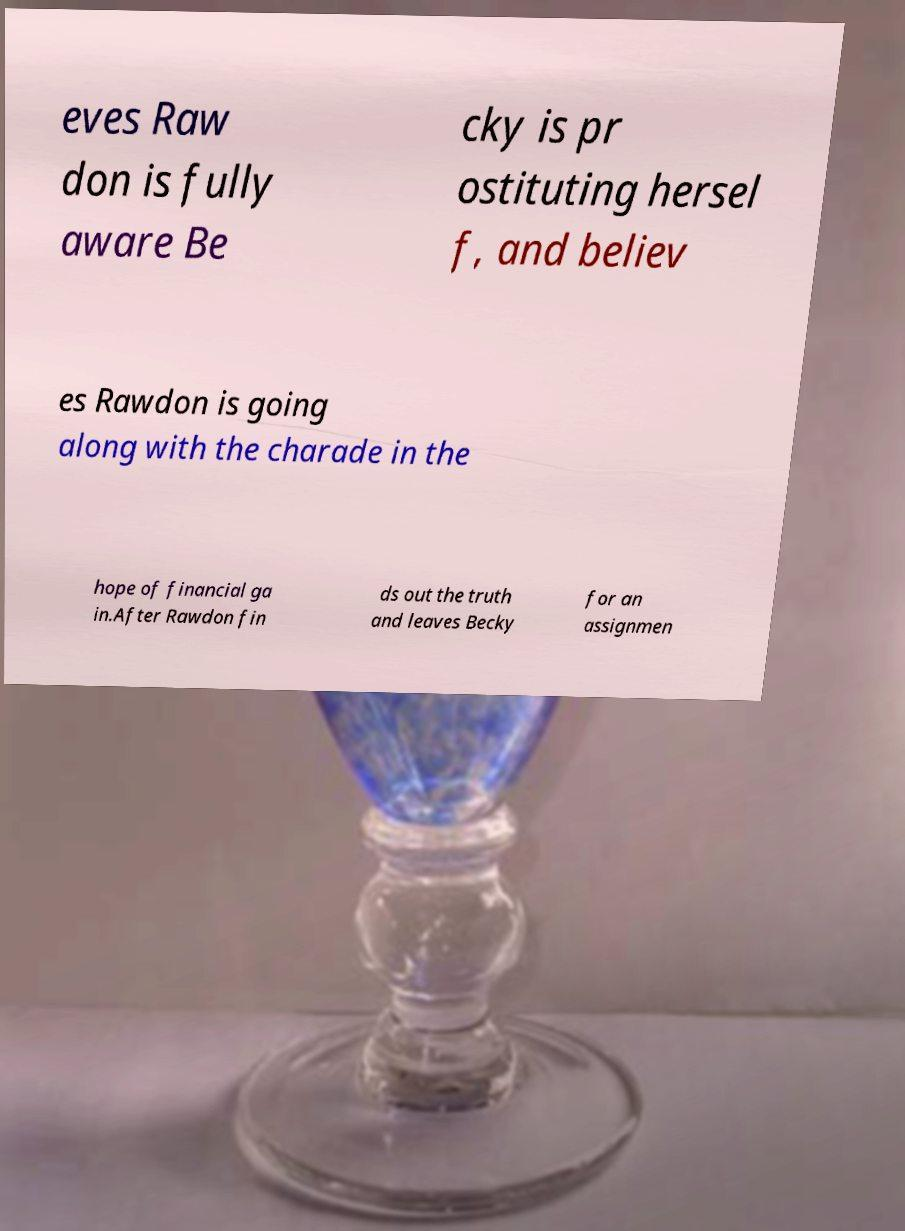Please identify and transcribe the text found in this image. eves Raw don is fully aware Be cky is pr ostituting hersel f, and believ es Rawdon is going along with the charade in the hope of financial ga in.After Rawdon fin ds out the truth and leaves Becky for an assignmen 